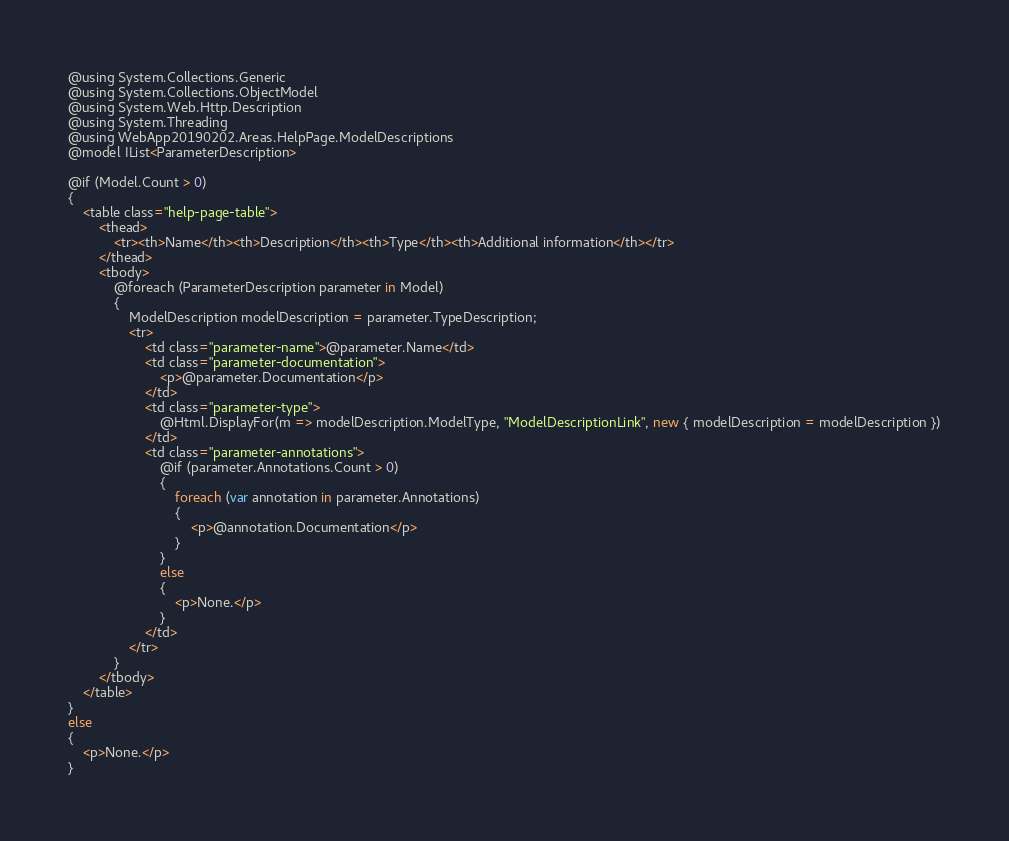Convert code to text. <code><loc_0><loc_0><loc_500><loc_500><_C#_>@using System.Collections.Generic
@using System.Collections.ObjectModel
@using System.Web.Http.Description
@using System.Threading
@using WebApp20190202.Areas.HelpPage.ModelDescriptions
@model IList<ParameterDescription>

@if (Model.Count > 0)
{
    <table class="help-page-table">
        <thead>
            <tr><th>Name</th><th>Description</th><th>Type</th><th>Additional information</th></tr>
        </thead>
        <tbody>
            @foreach (ParameterDescription parameter in Model)
            {
                ModelDescription modelDescription = parameter.TypeDescription;
                <tr>
                    <td class="parameter-name">@parameter.Name</td>
                    <td class="parameter-documentation">
                        <p>@parameter.Documentation</p>
                    </td>
                    <td class="parameter-type">
                        @Html.DisplayFor(m => modelDescription.ModelType, "ModelDescriptionLink", new { modelDescription = modelDescription })
                    </td>
                    <td class="parameter-annotations">
                        @if (parameter.Annotations.Count > 0)
                        {
                            foreach (var annotation in parameter.Annotations)
                            {
                                <p>@annotation.Documentation</p>
                            }
                        }
                        else
                        {
                            <p>None.</p>
                        }
                    </td>
                </tr>
            }
        </tbody>
    </table>
}
else
{
    <p>None.</p>
}

</code> 